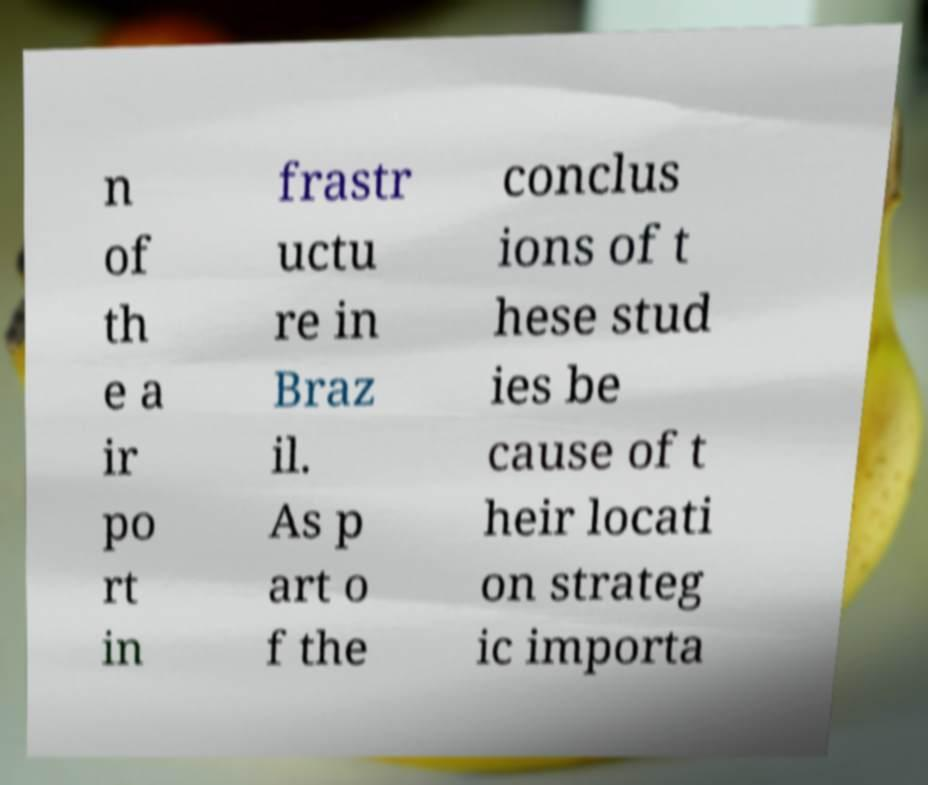Please read and relay the text visible in this image. What does it say? n of th e a ir po rt in frastr uctu re in Braz il. As p art o f the conclus ions of t hese stud ies be cause of t heir locati on strateg ic importa 